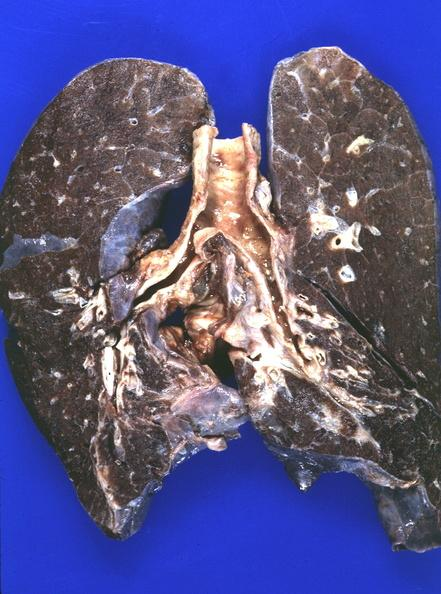s excellent example present?
Answer the question using a single word or phrase. No 